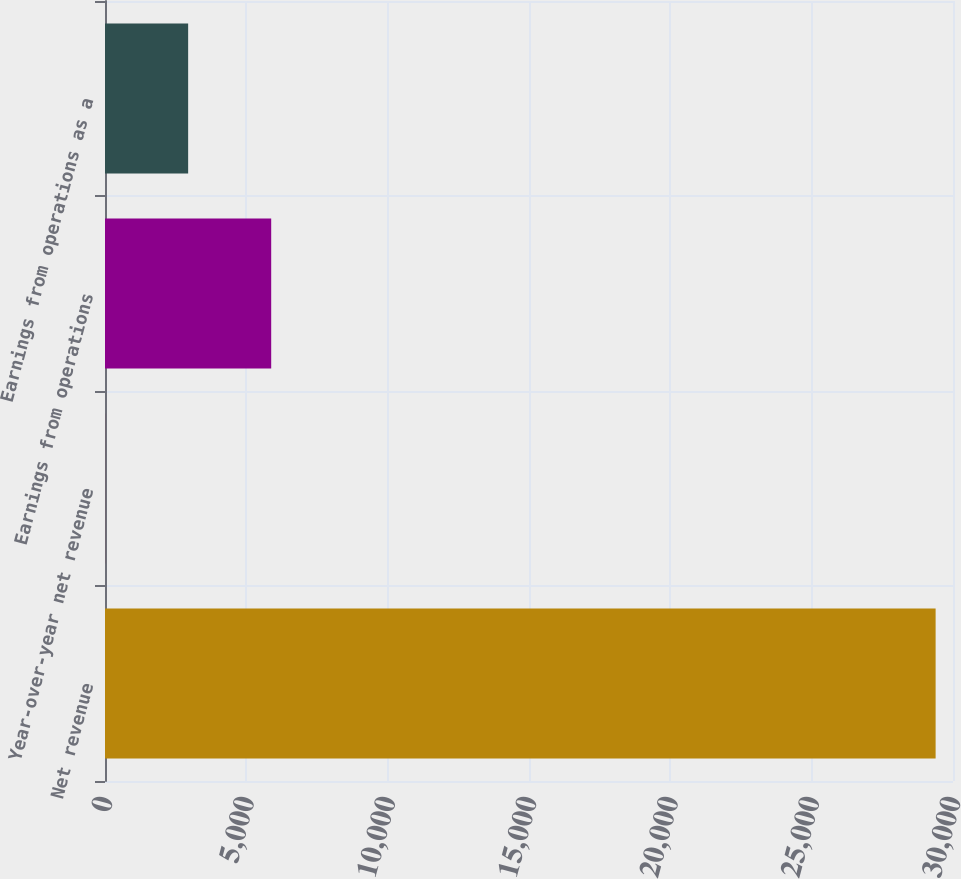Convert chart. <chart><loc_0><loc_0><loc_500><loc_500><bar_chart><fcel>Net revenue<fcel>Year-over-year net revenue<fcel>Earnings from operations<fcel>Earnings from operations as a<nl><fcel>29385<fcel>3.2<fcel>5879.56<fcel>2941.38<nl></chart> 